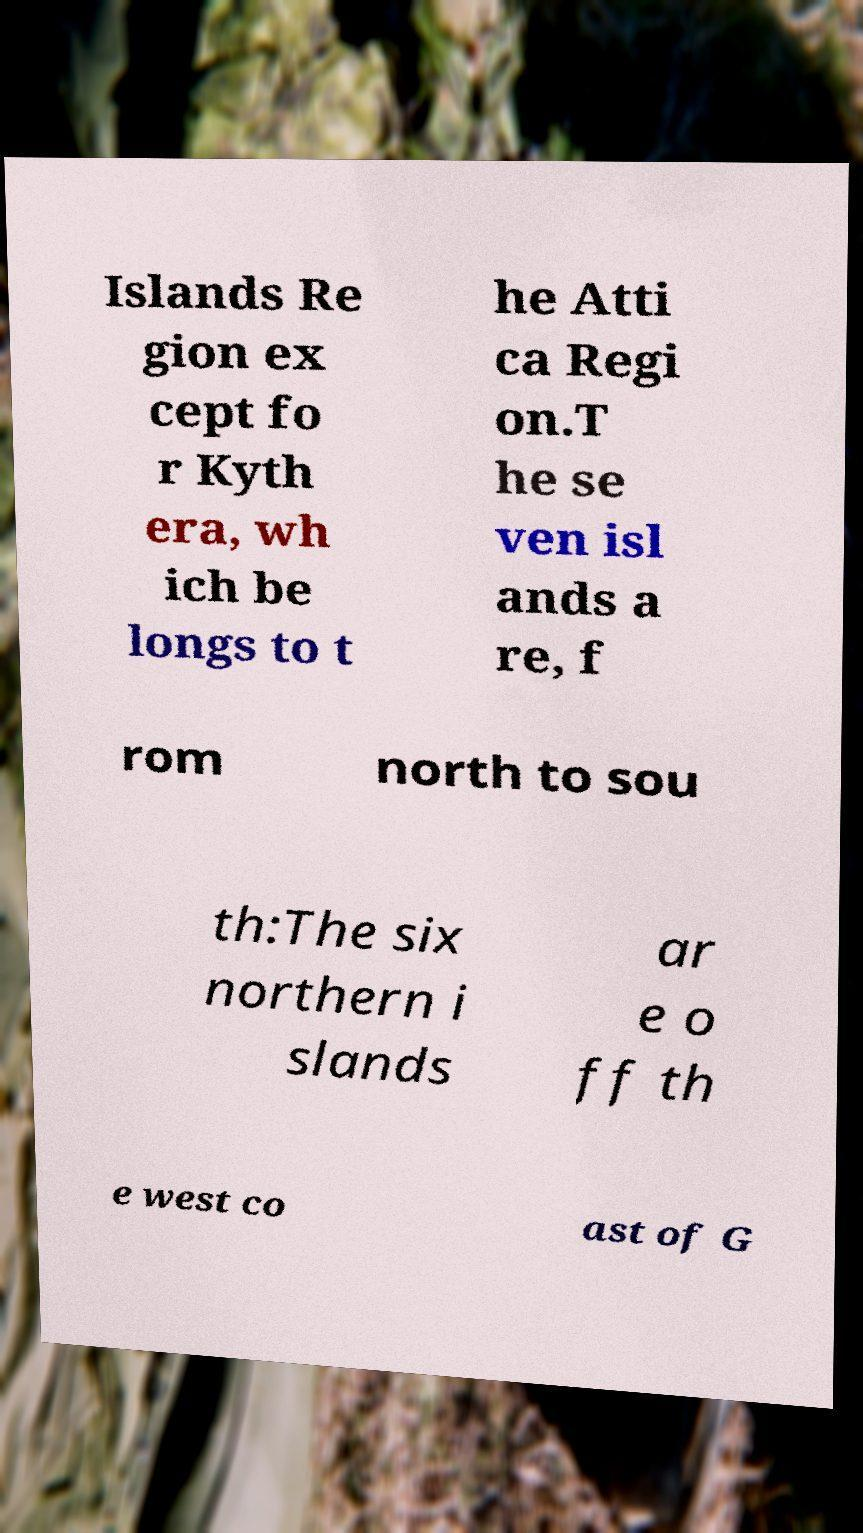Can you read and provide the text displayed in the image?This photo seems to have some interesting text. Can you extract and type it out for me? Islands Re gion ex cept fo r Kyth era, wh ich be longs to t he Atti ca Regi on.T he se ven isl ands a re, f rom north to sou th:The six northern i slands ar e o ff th e west co ast of G 